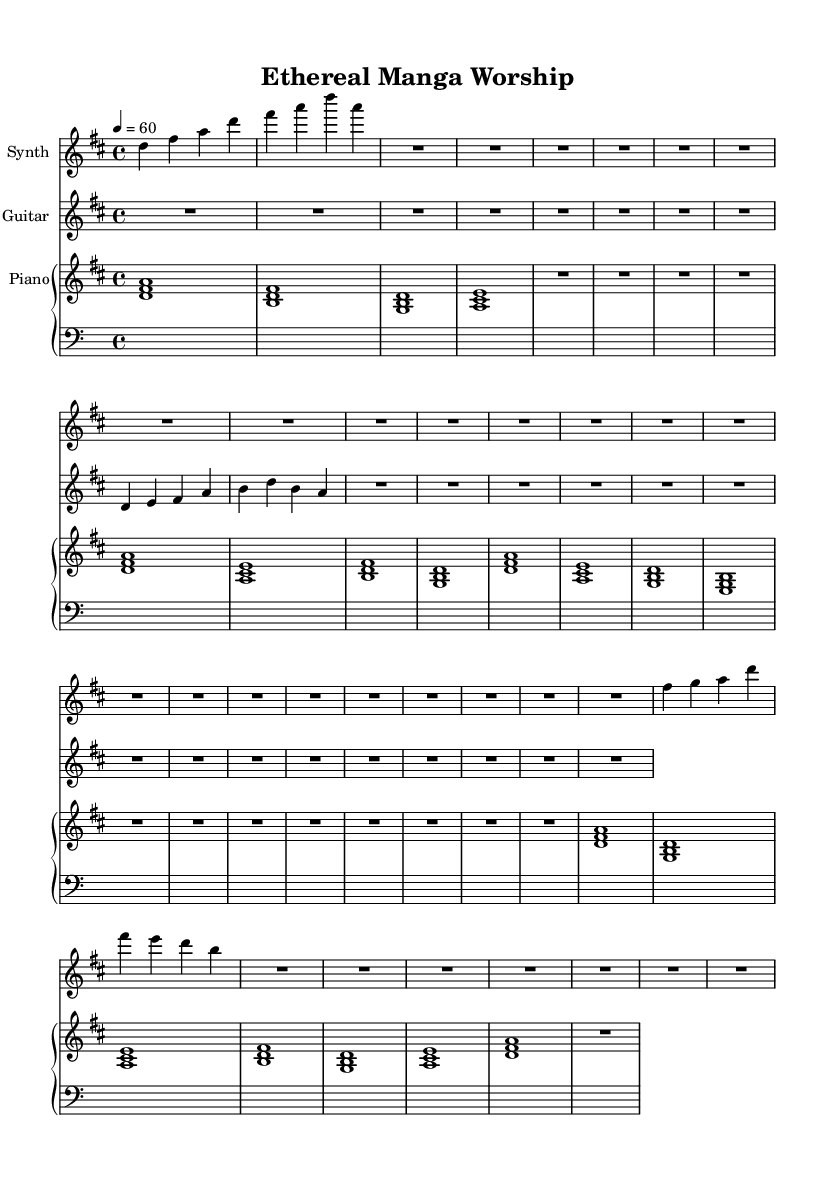What is the key signature of this music? The key signature is indicated at the beginning of the piece with the sharp signs placed on the staff. In this case, there is a single sharp (F#), which corresponds to D major.
Answer: D major What is the time signature of this music? The time signature is specified at the beginning of the score and shows that there are four beats in each measure (4/4).
Answer: 4/4 What tempo marking is indicated in the score? The tempo marking is found at the beginning of the piece and indicates that the tempo should be played at 60 beats per minute.
Answer: 60 beats per minute How many measures are in the synth melody? By counting the number of distinct segments divided by the barlines in the synth melody part, we find there are 6 measures present.
Answer: 6 measures What instruments are featured in this piece? The instruments are labeled in the score. They include Synth, Electric Guitar, and Piano.
Answer: Synth, Electric Guitar, Piano What is the primary chord played by the piano in the first measure? In the first measure, the piano chord consists of the notes D, F#, and A, which form a D major chord.
Answer: D major chord What kind of sound effects are referenced in the title of the sheet music? The title references subtle manga-inspired sound effects, suggesting an ethereal or atmospheric quality that ties in with the ambient worship music theme.
Answer: Subtle manga-inspired sound effects 